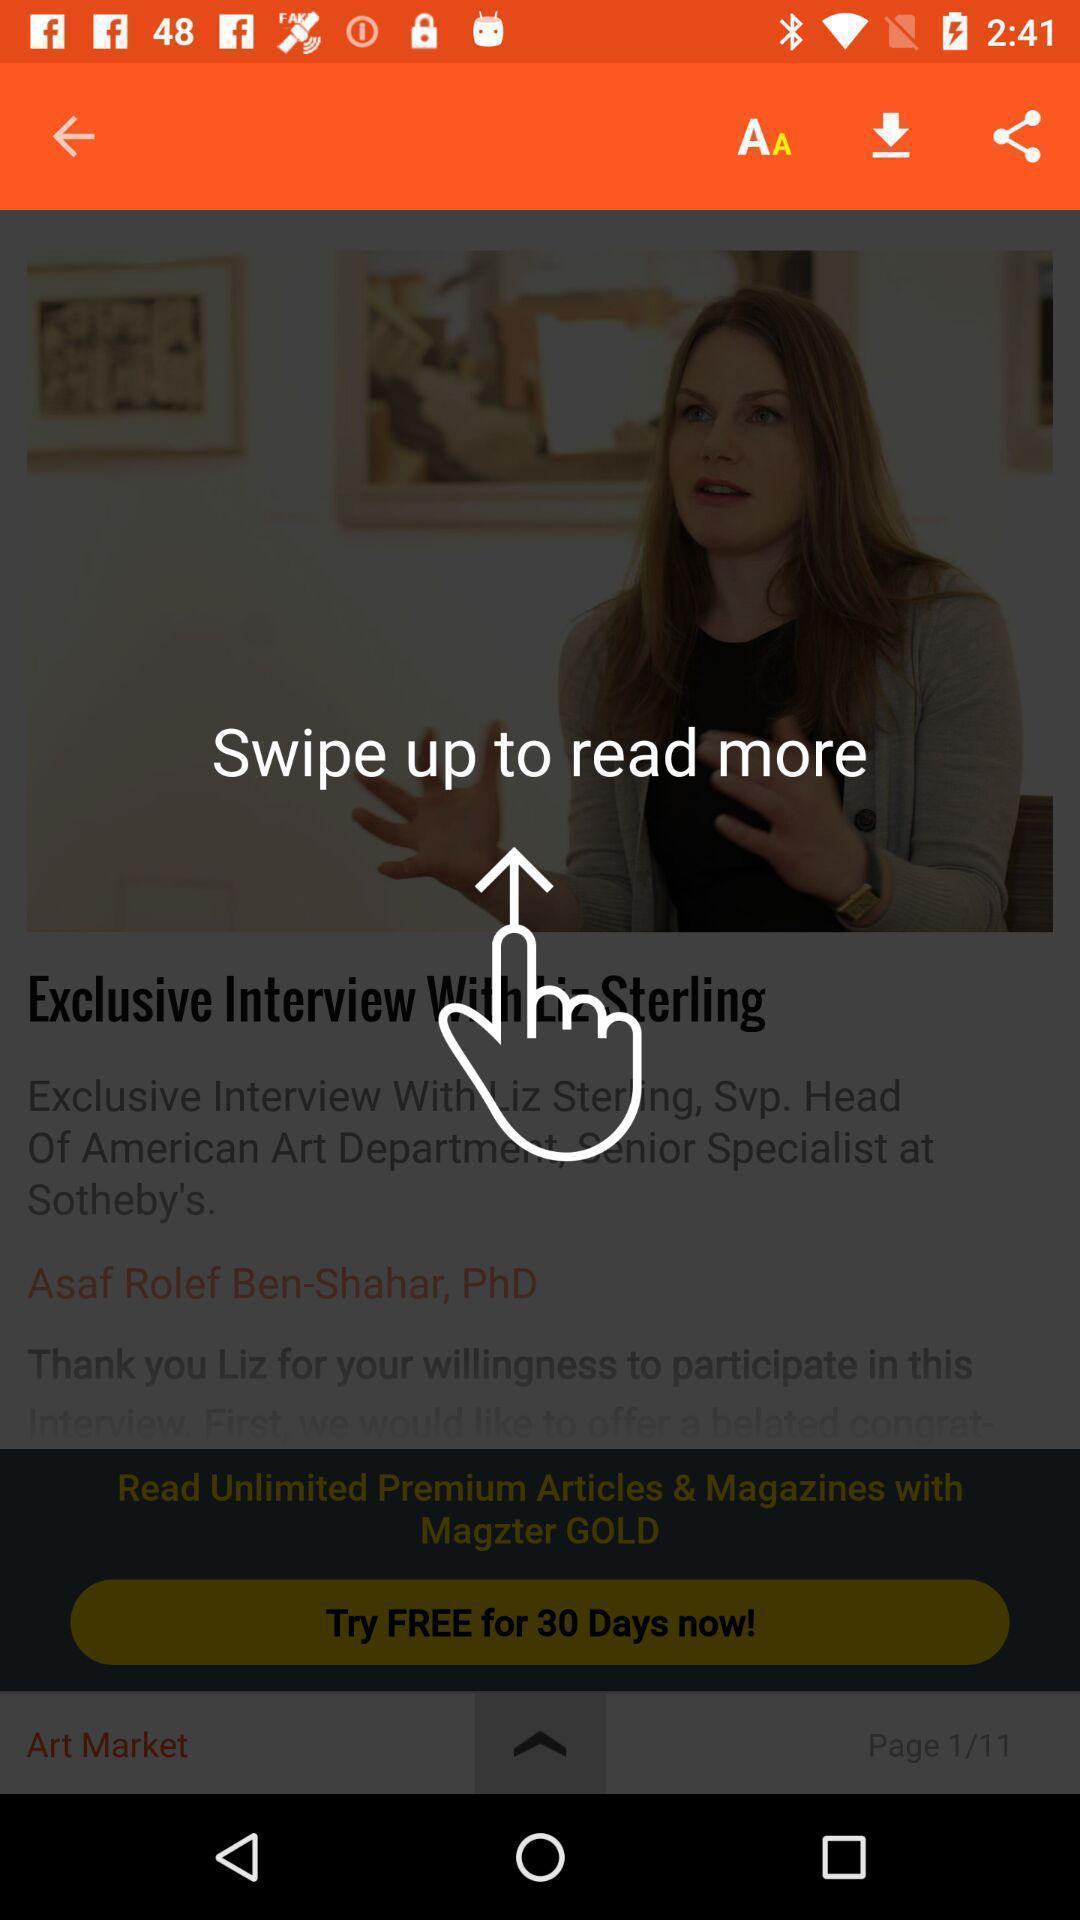Tell me what you see in this picture. Screen showing the swipe up tutorial. 